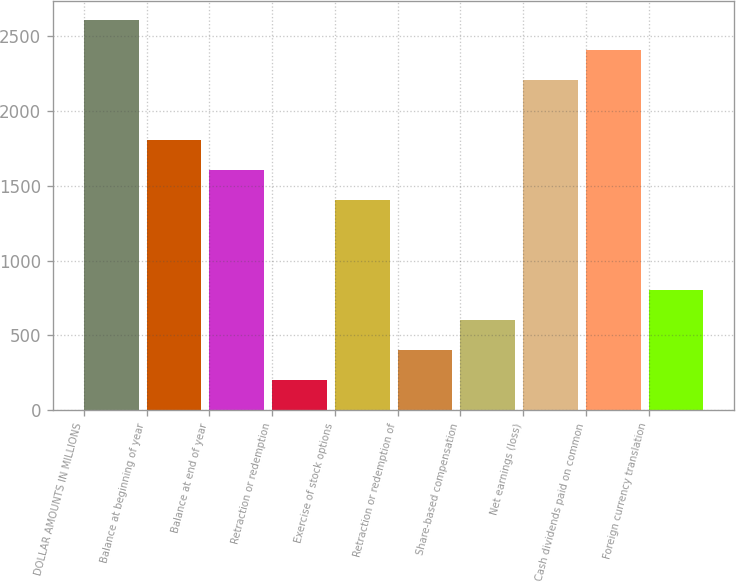<chart> <loc_0><loc_0><loc_500><loc_500><bar_chart><fcel>DOLLAR AMOUNTS IN MILLIONS<fcel>Balance at beginning of year<fcel>Balance at end of year<fcel>Retraction or redemption<fcel>Exercise of stock options<fcel>Retraction or redemption of<fcel>Share-based compensation<fcel>Net earnings (loss)<fcel>Cash dividends paid on common<fcel>Foreign currency translation<nl><fcel>2606.9<fcel>1805.7<fcel>1605.4<fcel>203.3<fcel>1405.1<fcel>403.6<fcel>603.9<fcel>2206.3<fcel>2406.6<fcel>804.2<nl></chart> 